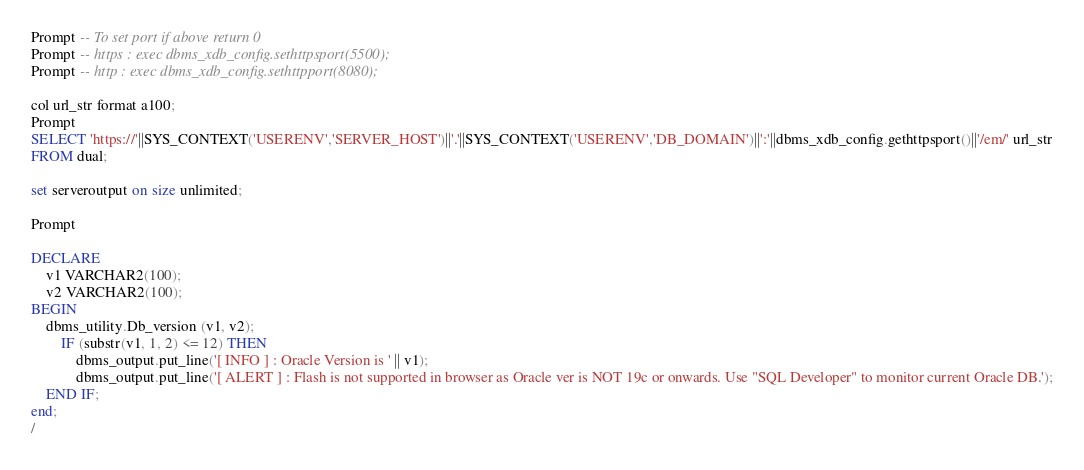<code> <loc_0><loc_0><loc_500><loc_500><_SQL_>
Prompt -- To set port if above return 0
Prompt -- https : exec dbms_xdb_config.sethttpsport(5500);
Prompt -- http : exec dbms_xdb_config.sethttpport(8080);

col url_str format a100;
Prompt
SELECT 'https://'||SYS_CONTEXT('USERENV','SERVER_HOST')||'.'||SYS_CONTEXT('USERENV','DB_DOMAIN')||':'||dbms_xdb_config.gethttpsport()||'/em/' url_str
FROM dual;

set serveroutput on size unlimited;

Prompt

DECLARE
    v1 VARCHAR2(100);
    v2 VARCHAR2(100);
BEGIN
    dbms_utility.Db_version (v1, v2);
        IF (substr(v1, 1, 2) <= 12) THEN
            dbms_output.put_line('[ INFO ] : Oracle Version is ' || v1);
            dbms_output.put_line('[ ALERT ] : Flash is not supported in browser as Oracle ver is NOT 19c or onwards. Use "SQL Developer" to monitor current Oracle DB.');
    END IF;
end;
/
</code> 